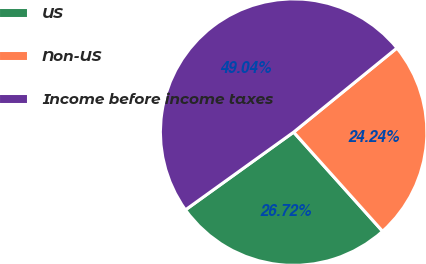Convert chart. <chart><loc_0><loc_0><loc_500><loc_500><pie_chart><fcel>US<fcel>Non-US<fcel>Income before income taxes<nl><fcel>26.72%<fcel>24.24%<fcel>49.04%<nl></chart> 